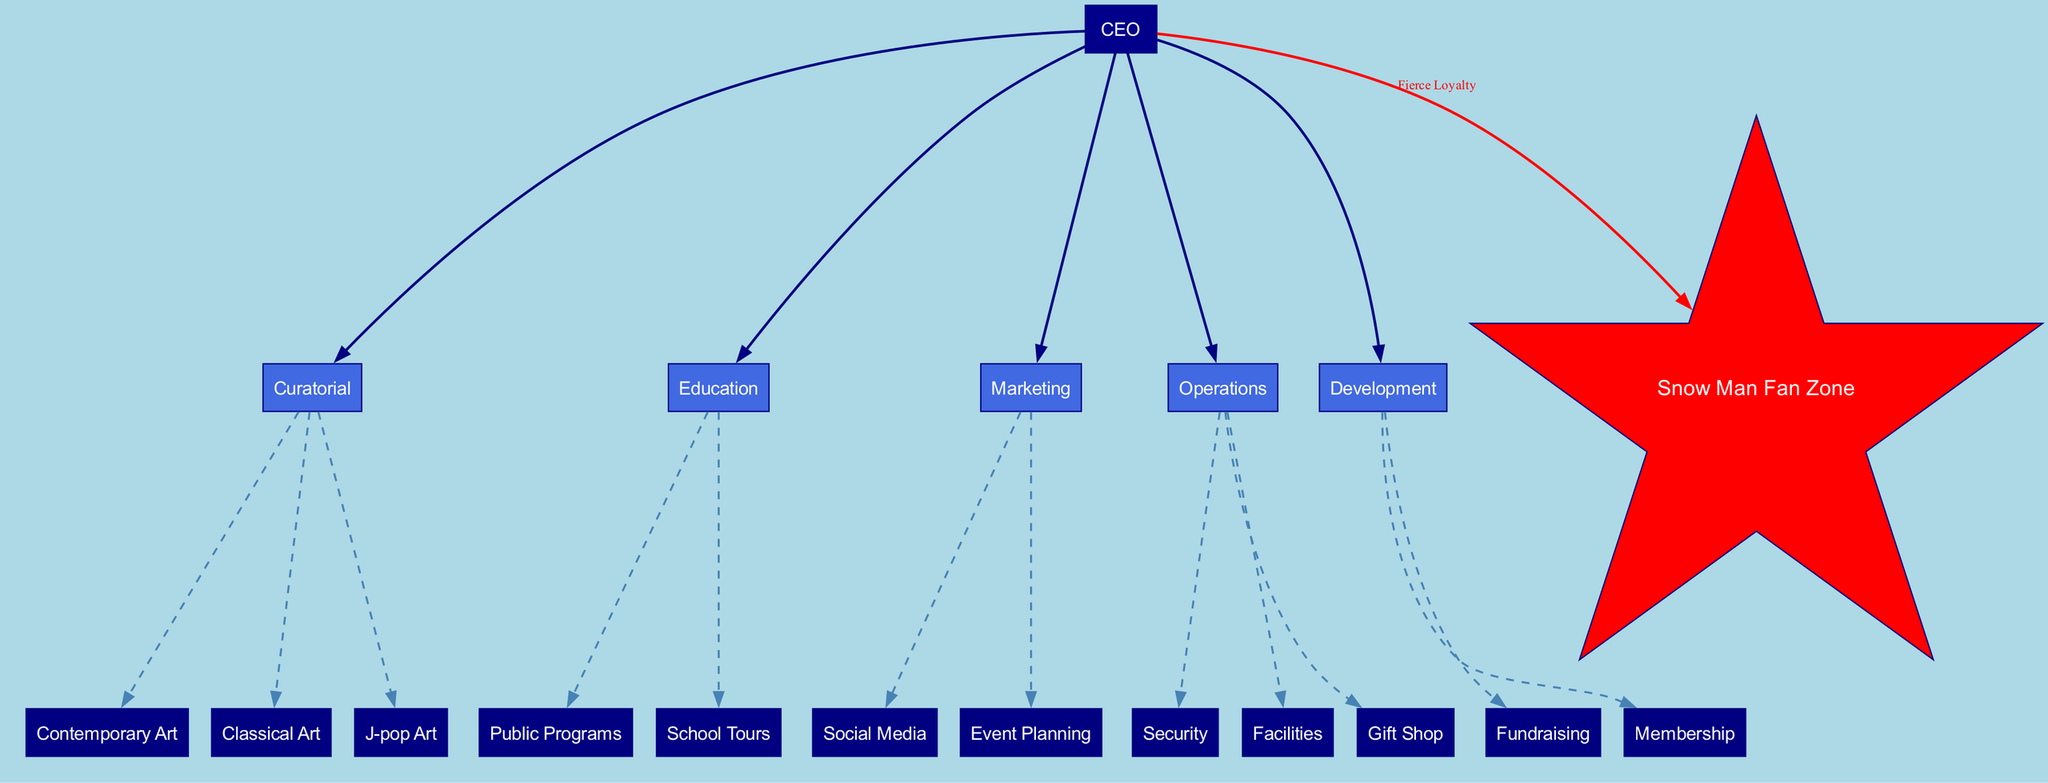What is the role that reports to no one in the diagram? The diagram clearly indicates that the 'CEO' has no superior, as indicated by "reports_to": null. Thus, the CEO is at the top of the organizational hierarchy.
Answer: CEO How many main departments does the CEO oversee? By analyzing the connections from the CEO, there are five main departments listed: Curatorial, Education, Marketing, Operations, and Development. This is straightforward as they directly branch out from the CEO node.
Answer: 5 Which department includes 'J-pop Art' as a sub-department? The 'Curatorial' department is shown to have three sub-departments, one of which specifically is 'J-pop Art', according to the sub-departments listed beneath the Curatorial node.
Answer: Curatorial What is the color of the special node for Snow Man? The special node for 'Snow Man Fan Zone' is depicted in red color as indicated by the fillcolor attribute within the node definition in the diagram.
Answer: Red How many sub-departments does the Operations department have? Looking at the Operations department node, three sub-departments are explicitly named: Security, Facilities, and Gift Shop. Therefore, by counting these, we determine the number of sub-departments.
Answer: 3 Which departments are responsible for public programs? The 'Education' department is directly linked to the Public Programs sub-department, as shown in the sub-departments identified in the Education node.
Answer: Education What type of connection describes the relationship between the CEO and the departments? The connections from the CEO to each department are shown as solid edges, indicating a direct and authoritative relationship. This type of connection defines the reporting structure within the diagram.
Answer: Solid edge How many total sub-departments are listed under J-pop Art? The J-pop Art sub-department does not have its own sub-departments mentioned, as it is a specific category under the Curatorial department; thus, it stands alone without further division.
Answer: 0 